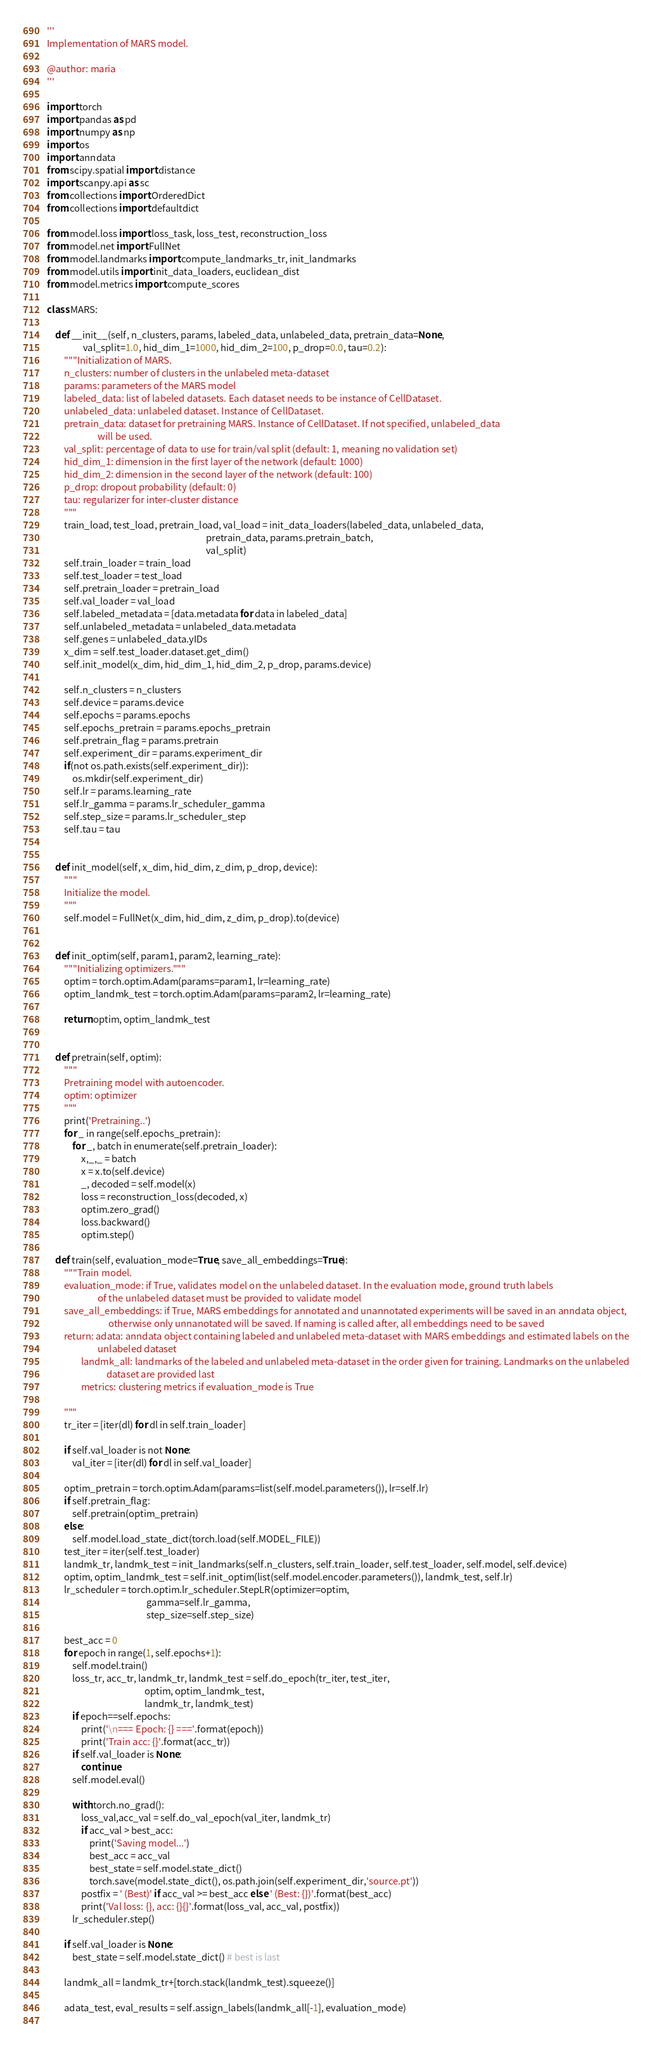Convert code to text. <code><loc_0><loc_0><loc_500><loc_500><_Python_>'''
Implementation of MARS model.

@author: maria
'''

import torch
import pandas as pd
import numpy as np
import os
import anndata
from scipy.spatial import distance
import scanpy.api as sc
from collections import OrderedDict
from collections import defaultdict

from model.loss import loss_task, loss_test, reconstruction_loss
from model.net import FullNet
from model.landmarks import compute_landmarks_tr, init_landmarks
from model.utils import init_data_loaders, euclidean_dist
from model.metrics import compute_scores

class MARS:
    
    def __init__(self, n_clusters, params, labeled_data, unlabeled_data, pretrain_data=None, 
                 val_split=1.0, hid_dim_1=1000, hid_dim_2=100, p_drop=0.0, tau=0.2):
        """Initialization of MARS.
        n_clusters: number of clusters in the unlabeled meta-dataset
        params: parameters of the MARS model
        labeled_data: list of labeled datasets. Each dataset needs to be instance of CellDataset.
        unlabeled_data: unlabeled dataset. Instance of CellDataset.
        pretrain_data: dataset for pretraining MARS. Instance of CellDataset. If not specified, unlabeled_data
                        will be used.
        val_split: percentage of data to use for train/val split (default: 1, meaning no validation set)
        hid_dim_1: dimension in the first layer of the network (default: 1000)
        hid_dim_2: dimension in the second layer of the network (default: 100)
        p_drop: dropout probability (default: 0)
        tau: regularizer for inter-cluster distance
        """
        train_load, test_load, pretrain_load, val_load = init_data_loaders(labeled_data, unlabeled_data, 
                                                                           pretrain_data, params.pretrain_batch, 
                                                                           val_split)
        self.train_loader = train_load
        self.test_loader = test_load
        self.pretrain_loader = pretrain_load
        self.val_loader = val_load
        self.labeled_metadata = [data.metadata for data in labeled_data]
        self.unlabeled_metadata = unlabeled_data.metadata
        self.genes = unlabeled_data.yIDs
        x_dim = self.test_loader.dataset.get_dim()
        self.init_model(x_dim, hid_dim_1, hid_dim_2, p_drop, params.device)
        
        self.n_clusters = n_clusters
        self.device = params.device
        self.epochs = params.epochs
        self.epochs_pretrain = params.epochs_pretrain
        self.pretrain_flag = params.pretrain
        self.experiment_dir = params.experiment_dir
        if(not os.path.exists(self.experiment_dir)):
            os.mkdir(self.experiment_dir)
        self.lr = params.learning_rate
        self.lr_gamma = params.lr_scheduler_gamma
        self.step_size = params.lr_scheduler_step
        self.tau = tau
        
 
    def init_model(self, x_dim, hid_dim, z_dim, p_drop, device):
        """
        Initialize the model.
        """
        self.model = FullNet(x_dim, hid_dim, z_dim, p_drop).to(device)
        
        
    def init_optim(self, param1, param2, learning_rate):
        """Initializing optimizers."""
        optim = torch.optim.Adam(params=param1, lr=learning_rate)
        optim_landmk_test = torch.optim.Adam(params=param2, lr=learning_rate)
        
        return optim, optim_landmk_test
    
    
    def pretrain(self, optim):
        """
        Pretraining model with autoencoder.
        optim: optimizer
        """
        print('Pretraining..')
        for _ in range(self.epochs_pretrain):
            for _, batch in enumerate(self.pretrain_loader):
                x,_,_ = batch
                x = x.to(self.device)
                _, decoded = self.model(x)
                loss = reconstruction_loss(decoded, x)
                optim.zero_grad()              
                loss.backward()                    
                optim.step() 
    
    def train(self, evaluation_mode=True, save_all_embeddings=True):
        """Train model.
        evaluation_mode: if True, validates model on the unlabeled dataset. In the evaluation mode, ground truth labels
                        of the unlabeled dataset must be provided to validate model
        save_all_embeddings: if True, MARS embeddings for annotated and unannotated experiments will be saved in an anndata object,
                             otherwise only unnanotated will be saved. If naming is called after, all embeddings need to be saved
        return: adata: anndata object containing labeled and unlabeled meta-dataset with MARS embeddings and estimated labels on the
                        unlabeled dataset
                landmk_all: landmarks of the labeled and unlabeled meta-dataset in the order given for training. Landmarks on the unlabeled
                            dataset are provided last
                metrics: clustering metrics if evaluation_mode is True
                
        """
        tr_iter = [iter(dl) for dl in self.train_loader]
        
        if self.val_loader is not None:
            val_iter = [iter(dl) for dl in self.val_loader]
    
        optim_pretrain = torch.optim.Adam(params=list(self.model.parameters()), lr=self.lr)
        if self.pretrain_flag:
            self.pretrain(optim_pretrain)
        else:
            self.model.load_state_dict(torch.load(self.MODEL_FILE))    
        test_iter = iter(self.test_loader)
        landmk_tr, landmk_test = init_landmarks(self.n_clusters, self.train_loader, self.test_loader, self.model, self.device)
        optim, optim_landmk_test = self.init_optim(list(self.model.encoder.parameters()), landmk_test, self.lr)
        lr_scheduler = torch.optim.lr_scheduler.StepLR(optimizer=optim,
                                               gamma=self.lr_gamma,
                                               step_size=self.step_size)
        
        best_acc = 0
        for epoch in range(1, self.epochs+1):
            self.model.train()
            loss_tr, acc_tr, landmk_tr, landmk_test = self.do_epoch(tr_iter, test_iter,
                                              optim, optim_landmk_test,
                                              landmk_tr, landmk_test)
            if epoch==self.epochs: 
                print('\n=== Epoch: {} ==='.format(epoch))
                print('Train acc: {}'.format(acc_tr))
            if self.val_loader is None:
                continue
            self.model.eval()
            
            with torch.no_grad():
                loss_val,acc_val = self.do_val_epoch(val_iter, landmk_tr)
                if acc_val > best_acc:
                    print('Saving model...')
                    best_acc = acc_val
                    best_state = self.model.state_dict()
                    torch.save(model.state_dict(), os.path.join(self.experiment_dir,'source.pt'))
                postfix = ' (Best)' if acc_val >= best_acc else ' (Best: {})'.format(best_acc)
                print('Val loss: {}, acc: {}{}'.format(loss_val, acc_val, postfix))
            lr_scheduler.step()
            
        if self.val_loader is None:
            best_state = self.model.state_dict() # best is last
        
        landmk_all = landmk_tr+[torch.stack(landmk_test).squeeze()]
        
        adata_test, eval_results = self.assign_labels(landmk_all[-1], evaluation_mode)
        </code> 